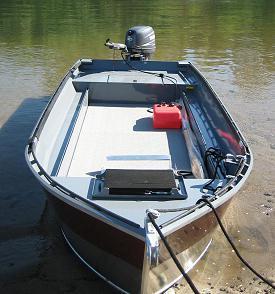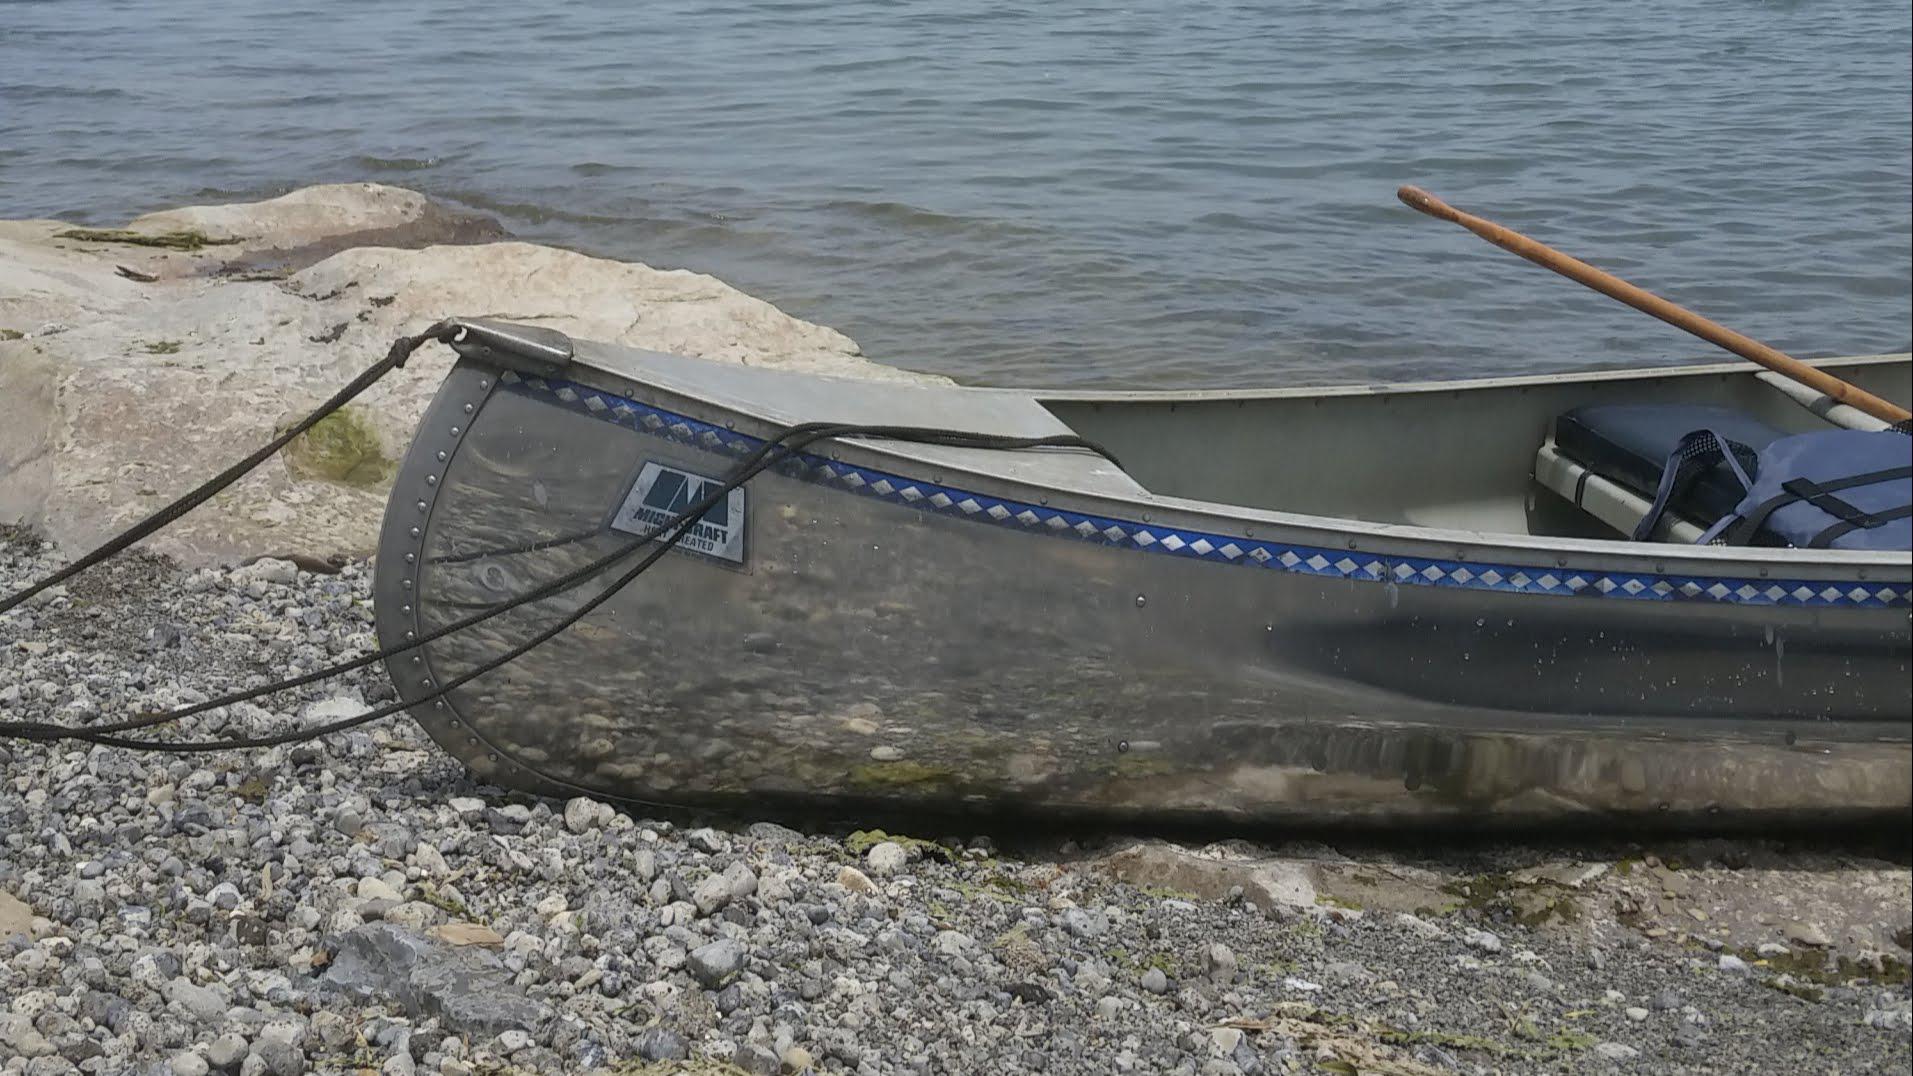The first image is the image on the left, the second image is the image on the right. Examine the images to the left and right. Is the description "At least one of the boats is not near water." accurate? Answer yes or no. No. The first image is the image on the left, the second image is the image on the right. Considering the images on both sides, is "At least one boat is not touching water." valid? Answer yes or no. No. 